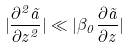<formula> <loc_0><loc_0><loc_500><loc_500>| \frac { \partial ^ { 2 } \tilde { a } } { \partial z ^ { 2 } } | \ll | \beta _ { 0 } \frac { \partial \tilde { a } } { \partial z } |</formula> 